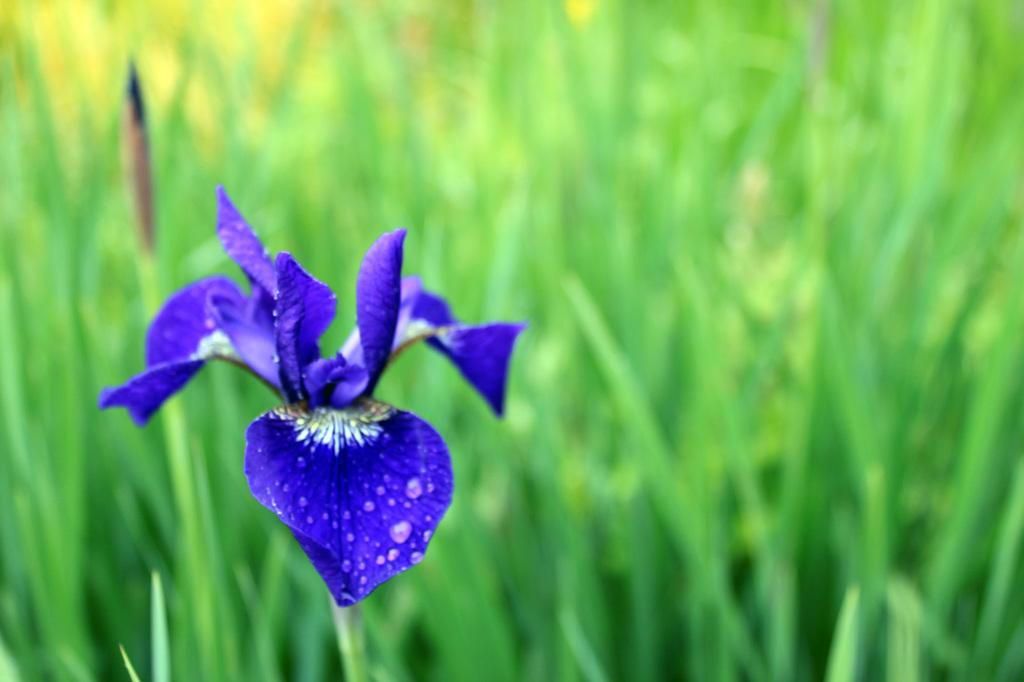What is the main subject of the image? There is a flower in the image. Can you describe the flower in more detail? The flower has water droplets on it. What can be seen in the background of the image? The background of the image is blurred, and there is greenery visible. What type of opinion does the flower have about the underwear in the image? There is no underwear present in the image, and flowers do not have opinions. 